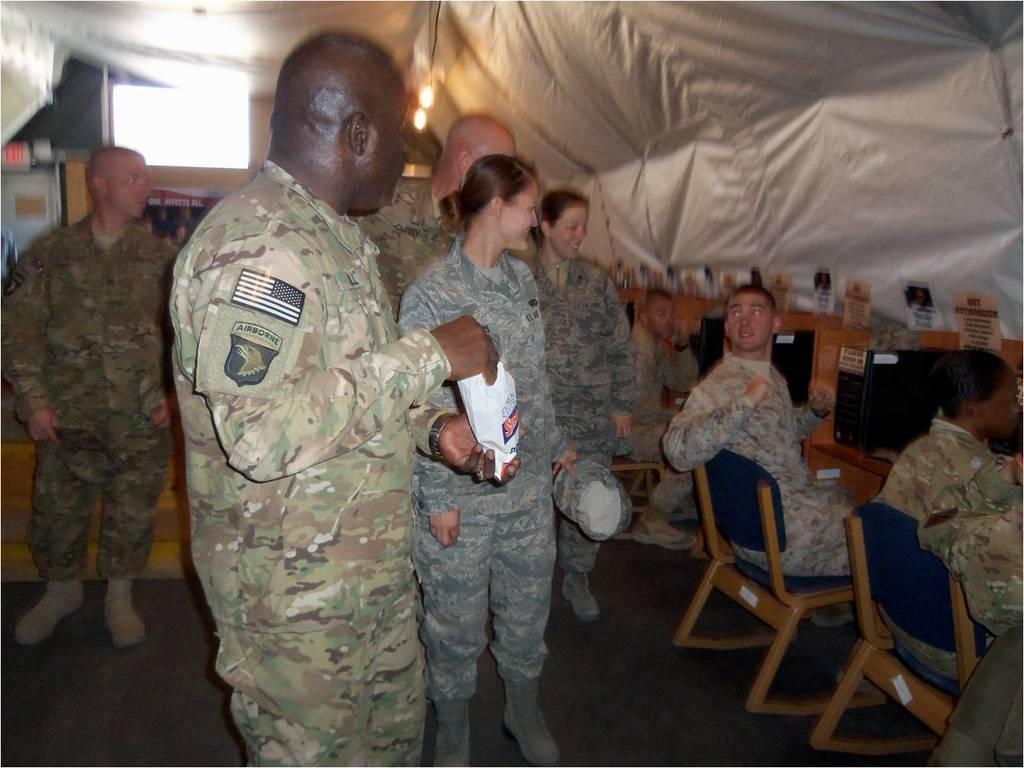Can you describe this image briefly? These persons are standing and these 3 persons are sitting on a chair. Every person wore a military dress. This person is holding a packet. This is tent. On this table there is a CPU, monitor and cards. 